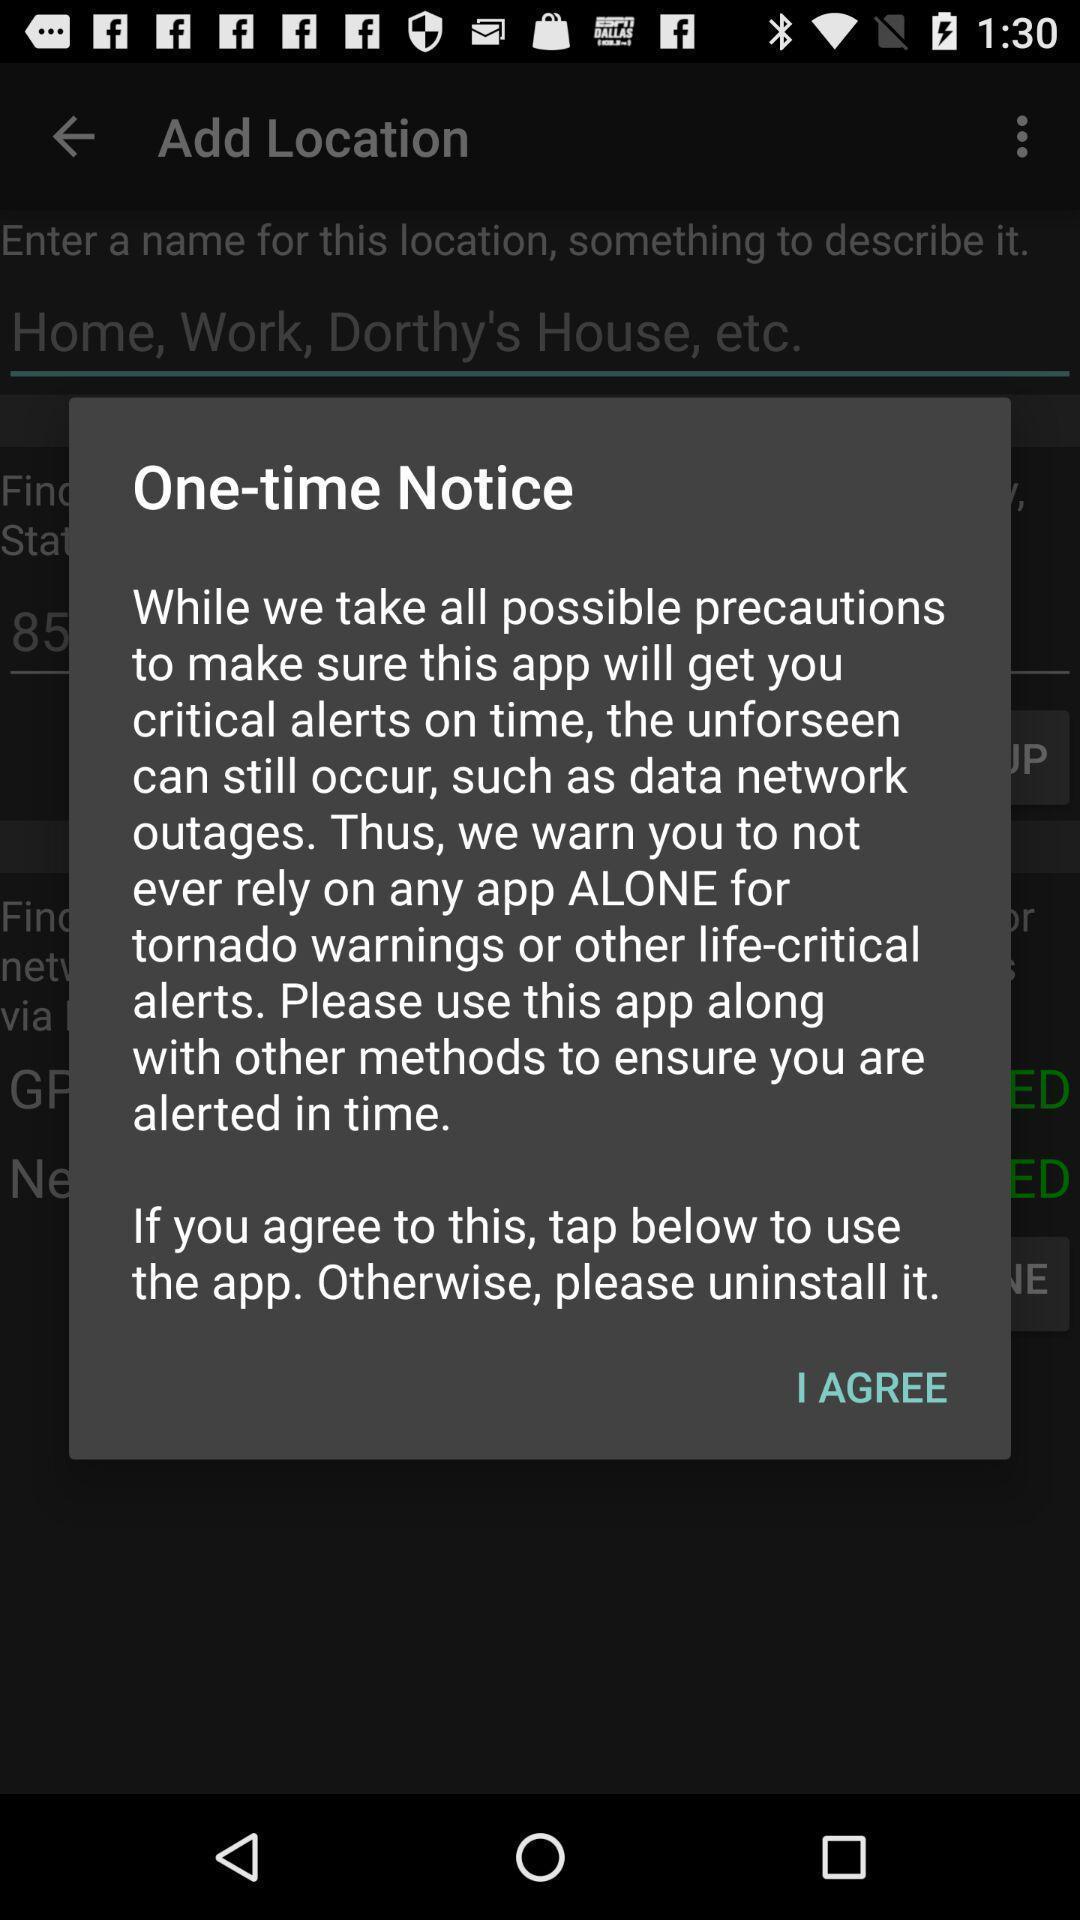Give me a summary of this screen capture. Pop-up displaying the one-time notice instruction. 